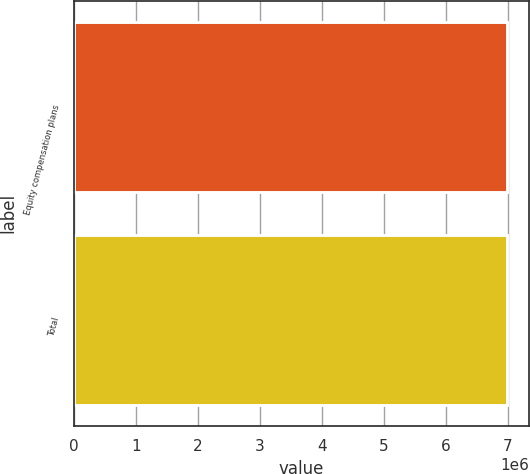Convert chart to OTSL. <chart><loc_0><loc_0><loc_500><loc_500><bar_chart><fcel>Equity compensation plans<fcel>Total<nl><fcel>6.9855e+06<fcel>6.9855e+06<nl></chart> 